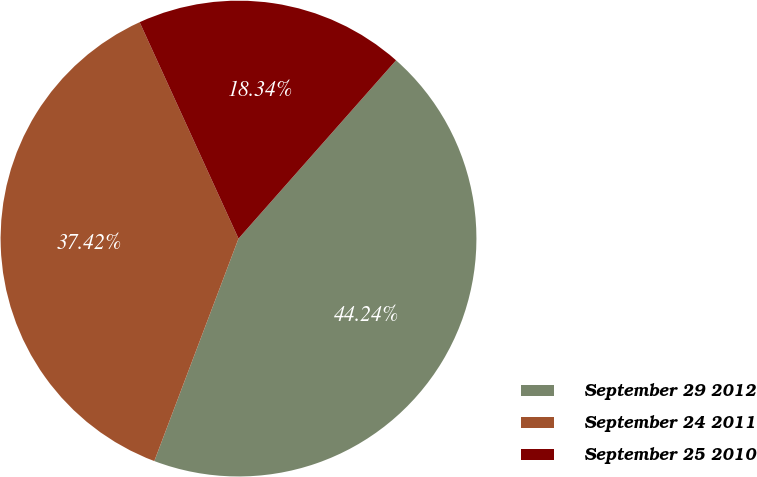Convert chart to OTSL. <chart><loc_0><loc_0><loc_500><loc_500><pie_chart><fcel>September 29 2012<fcel>September 24 2011<fcel>September 25 2010<nl><fcel>44.24%<fcel>37.42%<fcel>18.34%<nl></chart> 